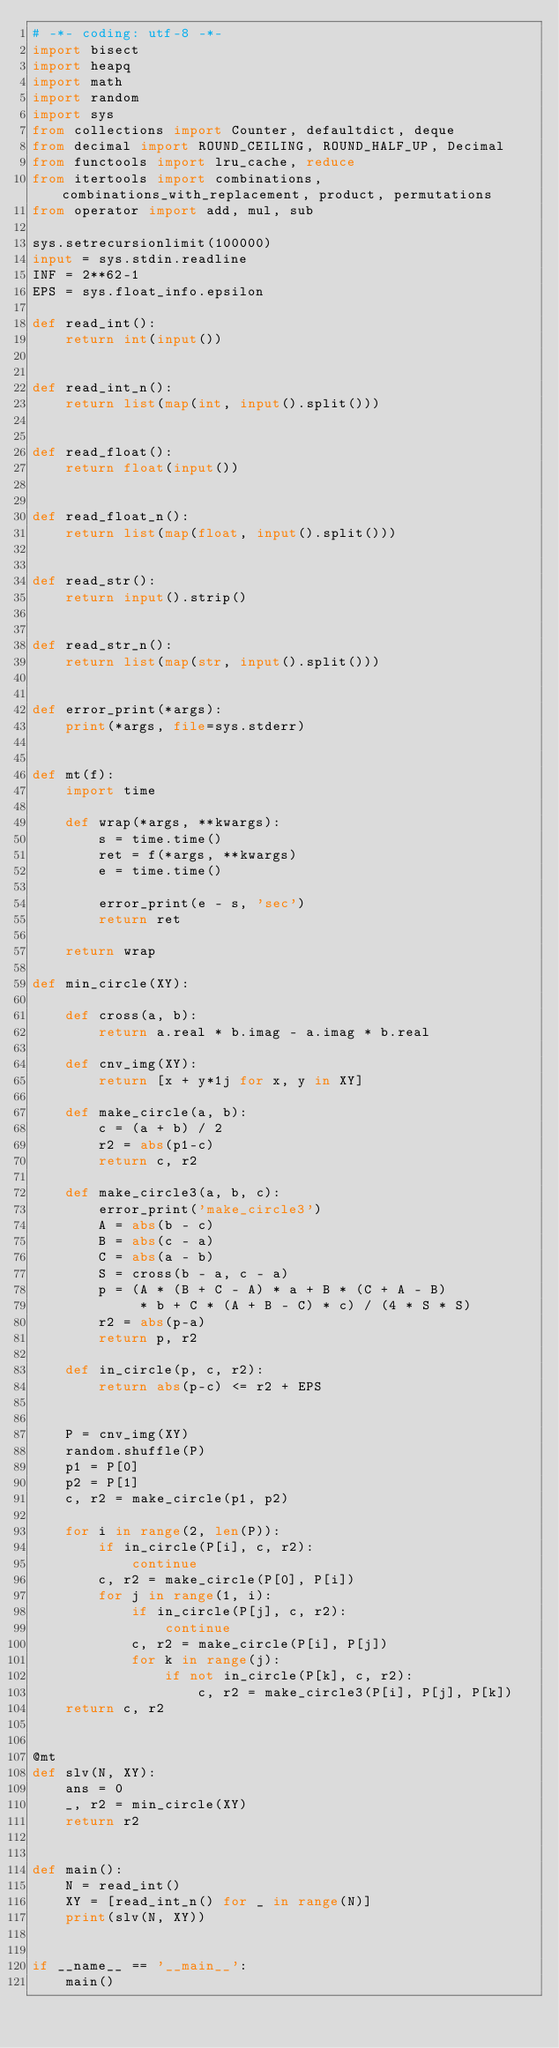Convert code to text. <code><loc_0><loc_0><loc_500><loc_500><_Python_># -*- coding: utf-8 -*-
import bisect
import heapq
import math
import random
import sys
from collections import Counter, defaultdict, deque
from decimal import ROUND_CEILING, ROUND_HALF_UP, Decimal
from functools import lru_cache, reduce
from itertools import combinations, combinations_with_replacement, product, permutations
from operator import add, mul, sub

sys.setrecursionlimit(100000)
input = sys.stdin.readline
INF = 2**62-1
EPS = sys.float_info.epsilon

def read_int():
    return int(input())


def read_int_n():
    return list(map(int, input().split()))


def read_float():
    return float(input())


def read_float_n():
    return list(map(float, input().split()))


def read_str():
    return input().strip()


def read_str_n():
    return list(map(str, input().split()))


def error_print(*args):
    print(*args, file=sys.stderr)


def mt(f):
    import time

    def wrap(*args, **kwargs):
        s = time.time()
        ret = f(*args, **kwargs)
        e = time.time()

        error_print(e - s, 'sec')
        return ret

    return wrap

def min_circle(XY):

    def cross(a, b):
        return a.real * b.imag - a.imag * b.real

    def cnv_img(XY):
        return [x + y*1j for x, y in XY]

    def make_circle(a, b):
        c = (a + b) / 2
        r2 = abs(p1-c)
        return c, r2

    def make_circle3(a, b, c):
        error_print('make_circle3')
        A = abs(b - c)
        B = abs(c - a)
        C = abs(a - b)
        S = cross(b - a, c - a)
        p = (A * (B + C - A) * a + B * (C + A - B)
             * b + C * (A + B - C) * c) / (4 * S * S)
        r2 = abs(p-a)
        return p, r2

    def in_circle(p, c, r2):
        return abs(p-c) <= r2 + EPS


    P = cnv_img(XY)
    random.shuffle(P)
    p1 = P[0]
    p2 = P[1]
    c, r2 = make_circle(p1, p2)

    for i in range(2, len(P)):
        if in_circle(P[i], c, r2):
            continue
        c, r2 = make_circle(P[0], P[i])
        for j in range(1, i):
            if in_circle(P[j], c, r2):
                continue
            c, r2 = make_circle(P[i], P[j])
            for k in range(j):
                if not in_circle(P[k], c, r2):
                    c, r2 = make_circle3(P[i], P[j], P[k])
    return c, r2


@mt
def slv(N, XY):
    ans = 0
    _, r2 = min_circle(XY)
    return r2


def main():
    N = read_int()
    XY = [read_int_n() for _ in range(N)]
    print(slv(N, XY))


if __name__ == '__main__':
    main()
</code> 